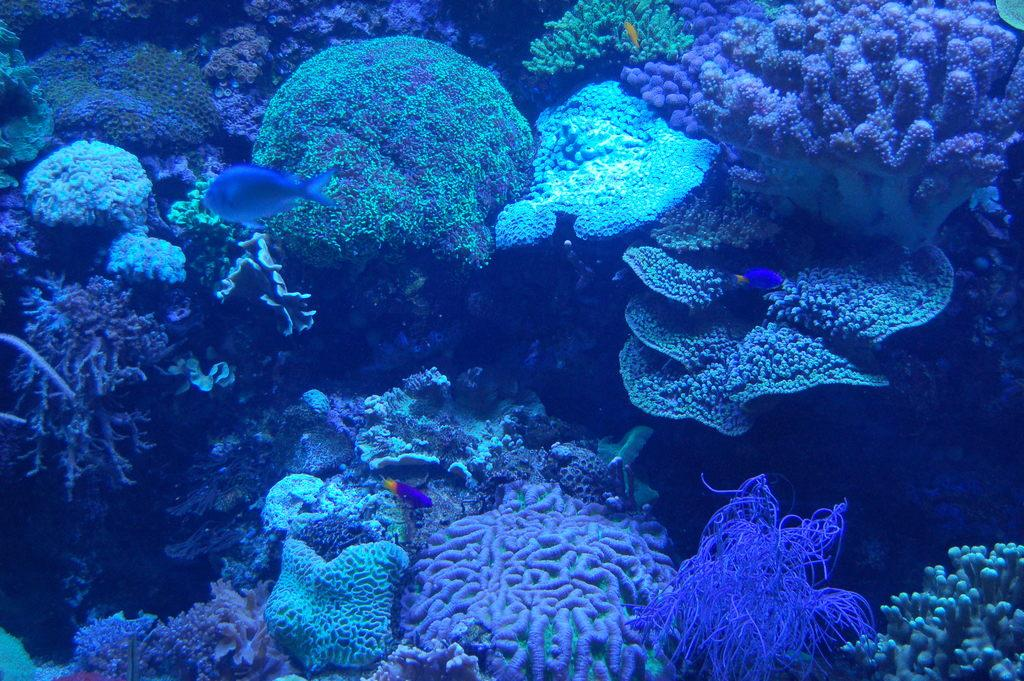What type of underwater environment is depicted in the image? There is a coral reef in the image. What kind of marine life can be seen in the image? There are fishes in the water in the image. What type of pipe can be seen in the image? There is no pipe present in the image; it is an underwater scene featuring a coral reef and fishes. 